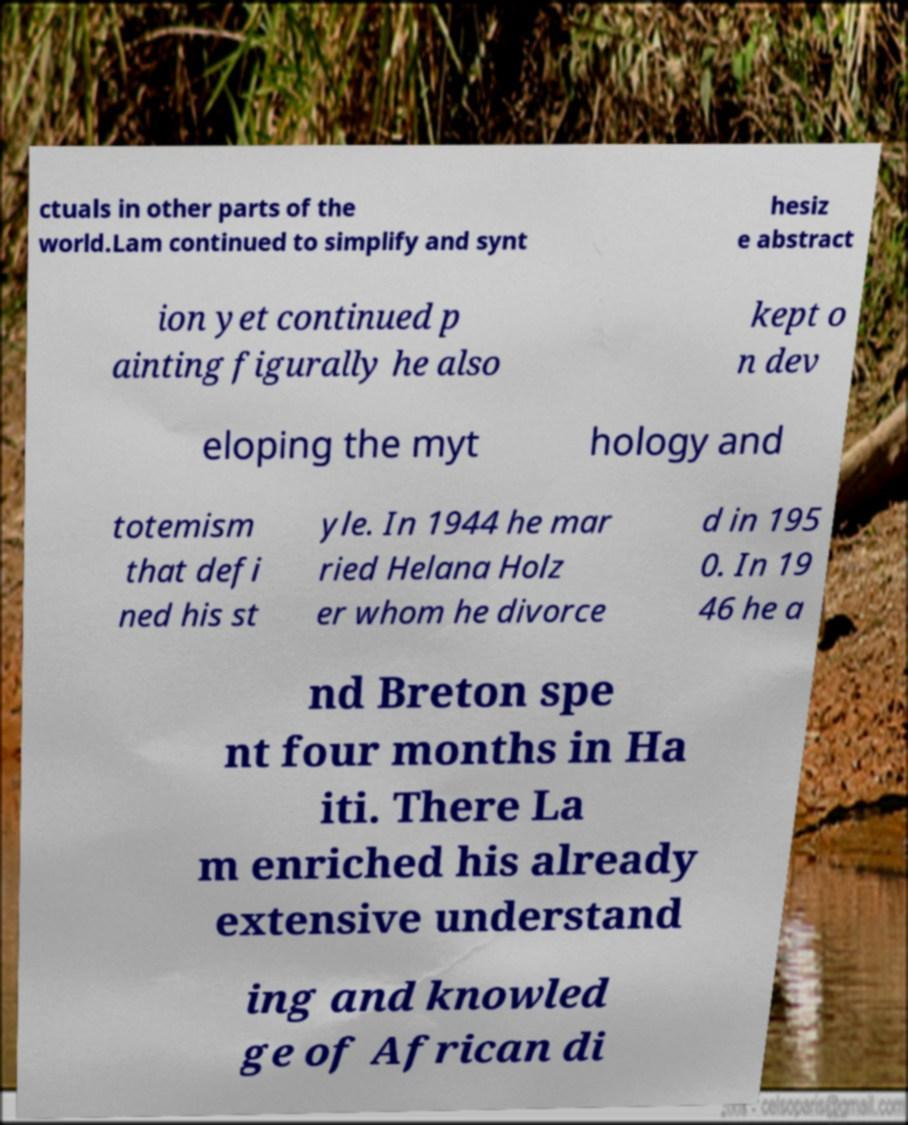Please read and relay the text visible in this image. What does it say? ctuals in other parts of the world.Lam continued to simplify and synt hesiz e abstract ion yet continued p ainting figurally he also kept o n dev eloping the myt hology and totemism that defi ned his st yle. In 1944 he mar ried Helana Holz er whom he divorce d in 195 0. In 19 46 he a nd Breton spe nt four months in Ha iti. There La m enriched his already extensive understand ing and knowled ge of African di 